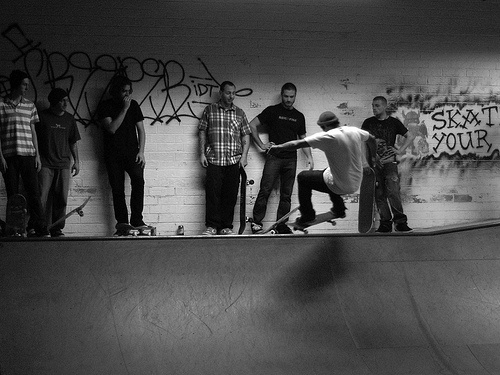Describe the objects in this image and their specific colors. I can see people in black, gray, darkgray, and lightgray tones, people in black, gray, darkgray, and lightgray tones, people in black, gray, and darkgray tones, people in black, gray, darkgray, and lightgray tones, and people in black and gray tones in this image. 